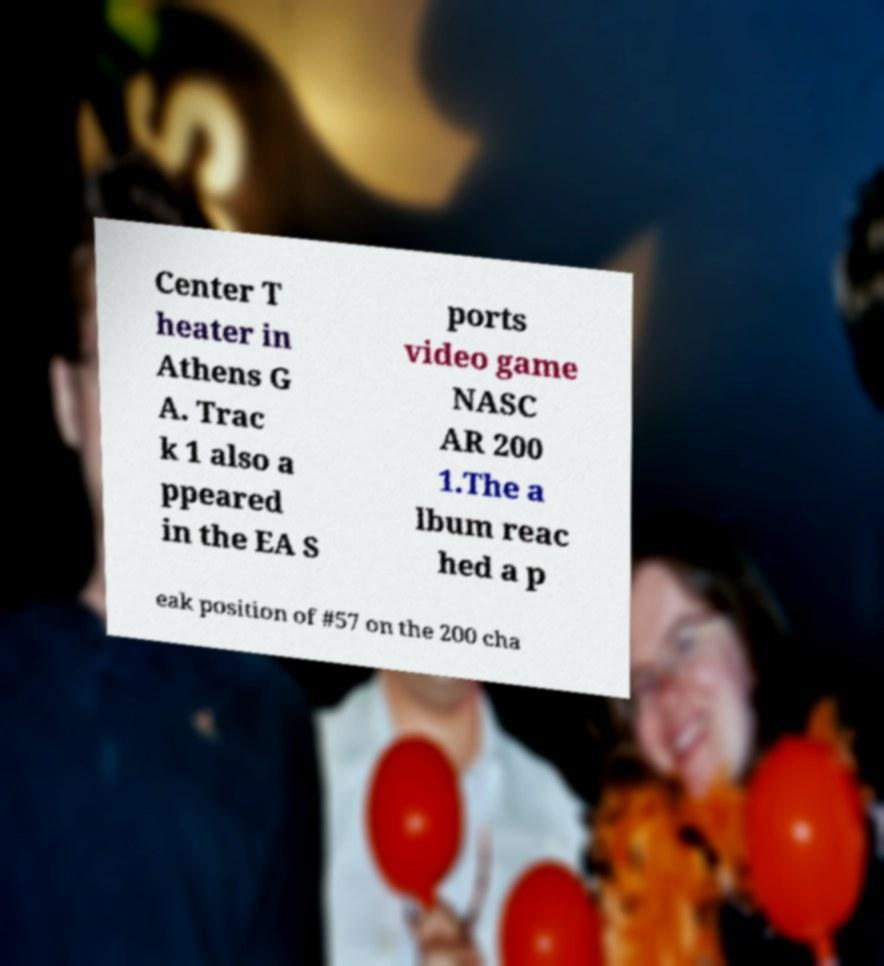Please identify and transcribe the text found in this image. Center T heater in Athens G A. Trac k 1 also a ppeared in the EA S ports video game NASC AR 200 1.The a lbum reac hed a p eak position of #57 on the 200 cha 